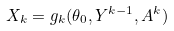<formula> <loc_0><loc_0><loc_500><loc_500>X _ { k } = g _ { k } ( \theta _ { 0 } , Y ^ { k - 1 } , A ^ { k } )</formula> 